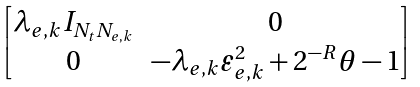Convert formula to latex. <formula><loc_0><loc_0><loc_500><loc_500>\begin{bmatrix} \lambda _ { e , k } { I } _ { N _ { t } N _ { e , k } } & { 0 } \\ { 0 } & - \lambda _ { e , k } \varepsilon _ { e , k } ^ { 2 } + 2 ^ { - R } \theta - 1 \end{bmatrix}</formula> 